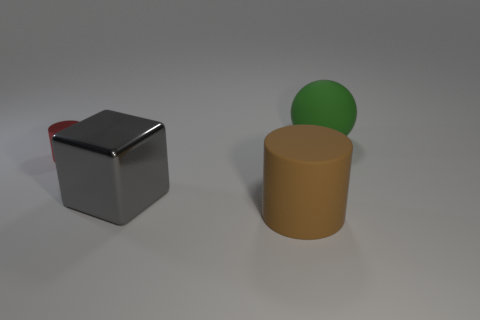Subtract all red cylinders. How many cylinders are left? 1 Subtract 1 balls. How many balls are left? 0 Add 1 tiny blue blocks. How many objects exist? 5 Subtract all blocks. How many objects are left? 3 Subtract all cyan balls. How many brown cylinders are left? 1 Subtract all tiny red metallic cylinders. Subtract all large gray blocks. How many objects are left? 2 Add 1 large green matte spheres. How many large green matte spheres are left? 2 Add 3 large green rubber objects. How many large green rubber objects exist? 4 Subtract 1 gray cubes. How many objects are left? 3 Subtract all brown cylinders. Subtract all yellow spheres. How many cylinders are left? 1 